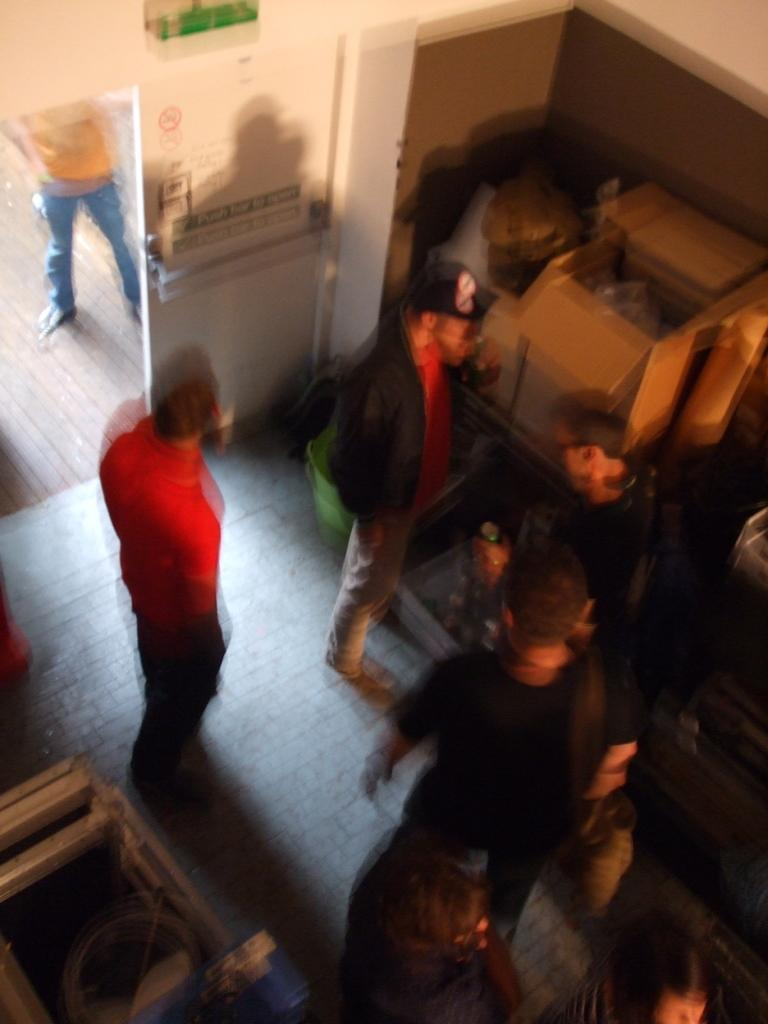What can be seen in the image involving human presence? There are people standing in the image. What objects are visible in the background of the image? There are boxes and wood visible in the background of the image. Can you describe a feature of the room or space in the image? There is a door in the image. What type of cub is playing with the story in the image? There is no cub or story present in the image. 